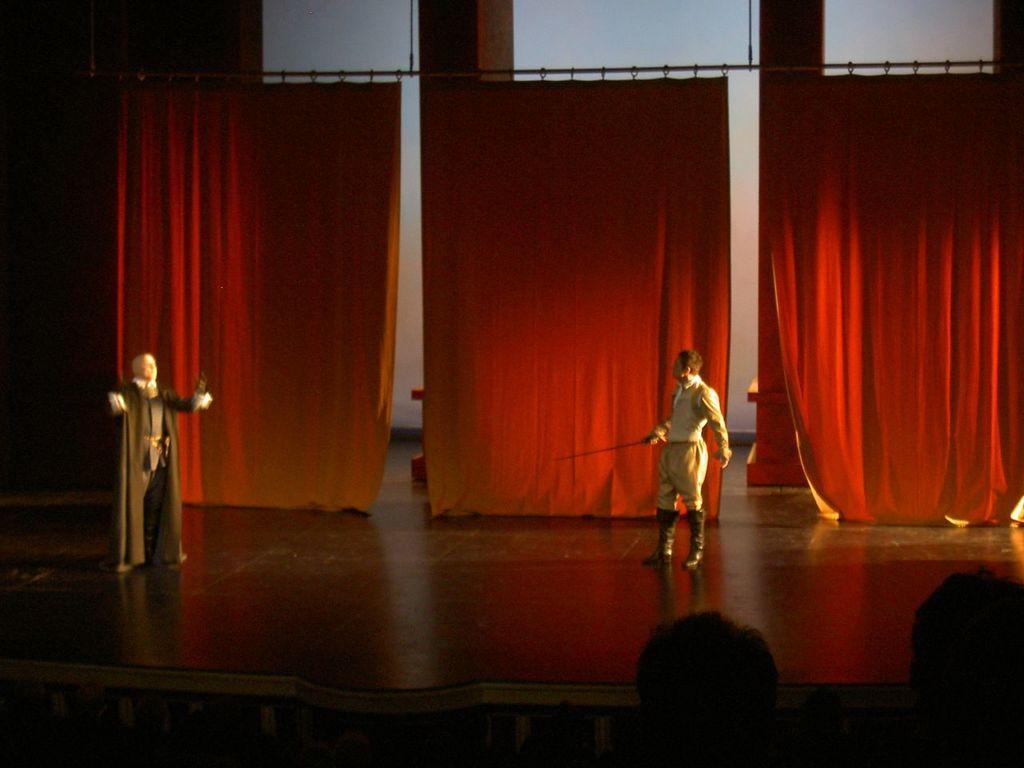Can you describe this image briefly? This picture describes about group of people, in the middle of the given image we can see a man, he is holding a sword, in the background we can find curtains. 